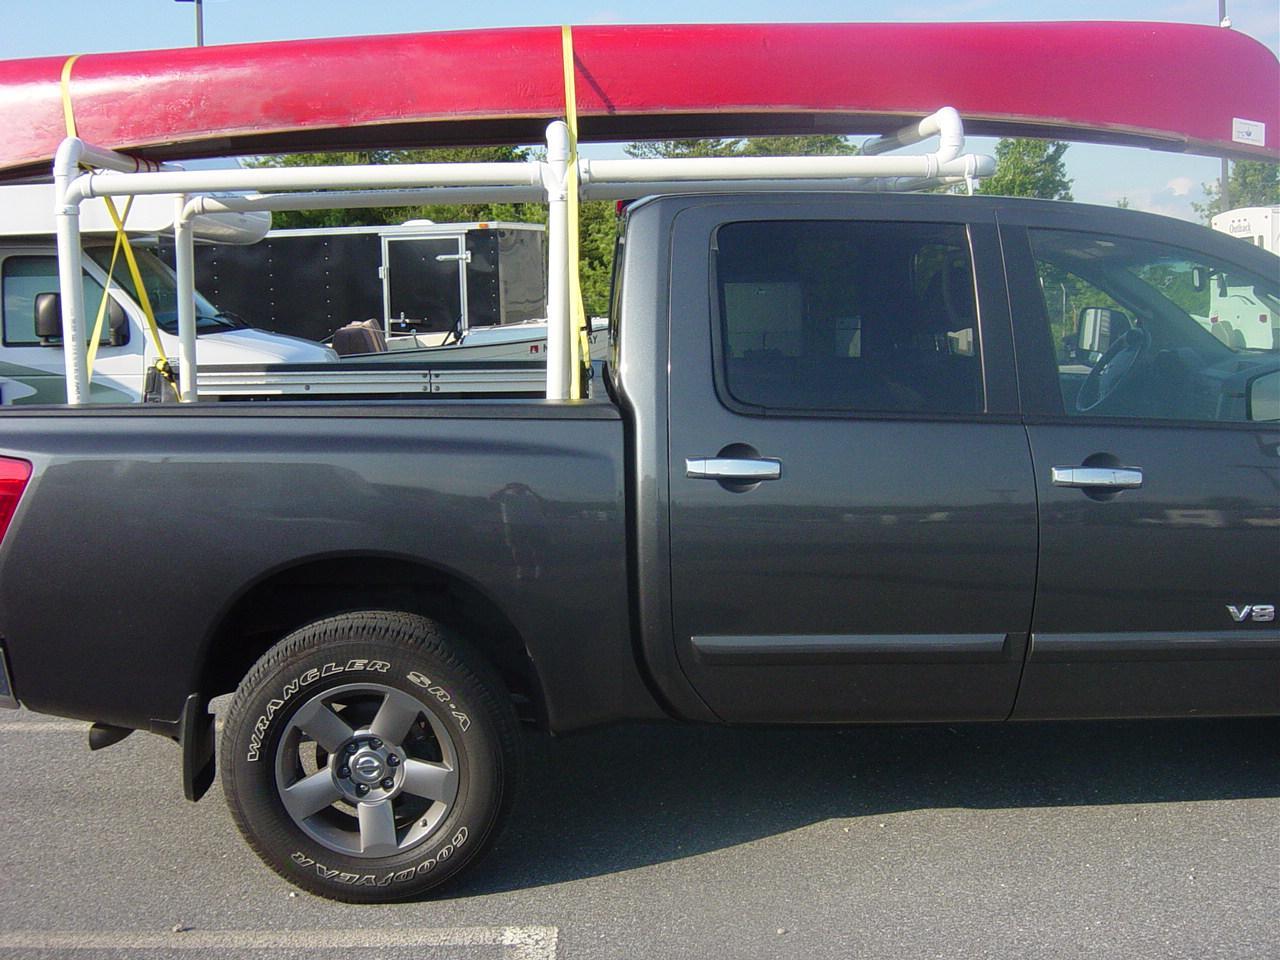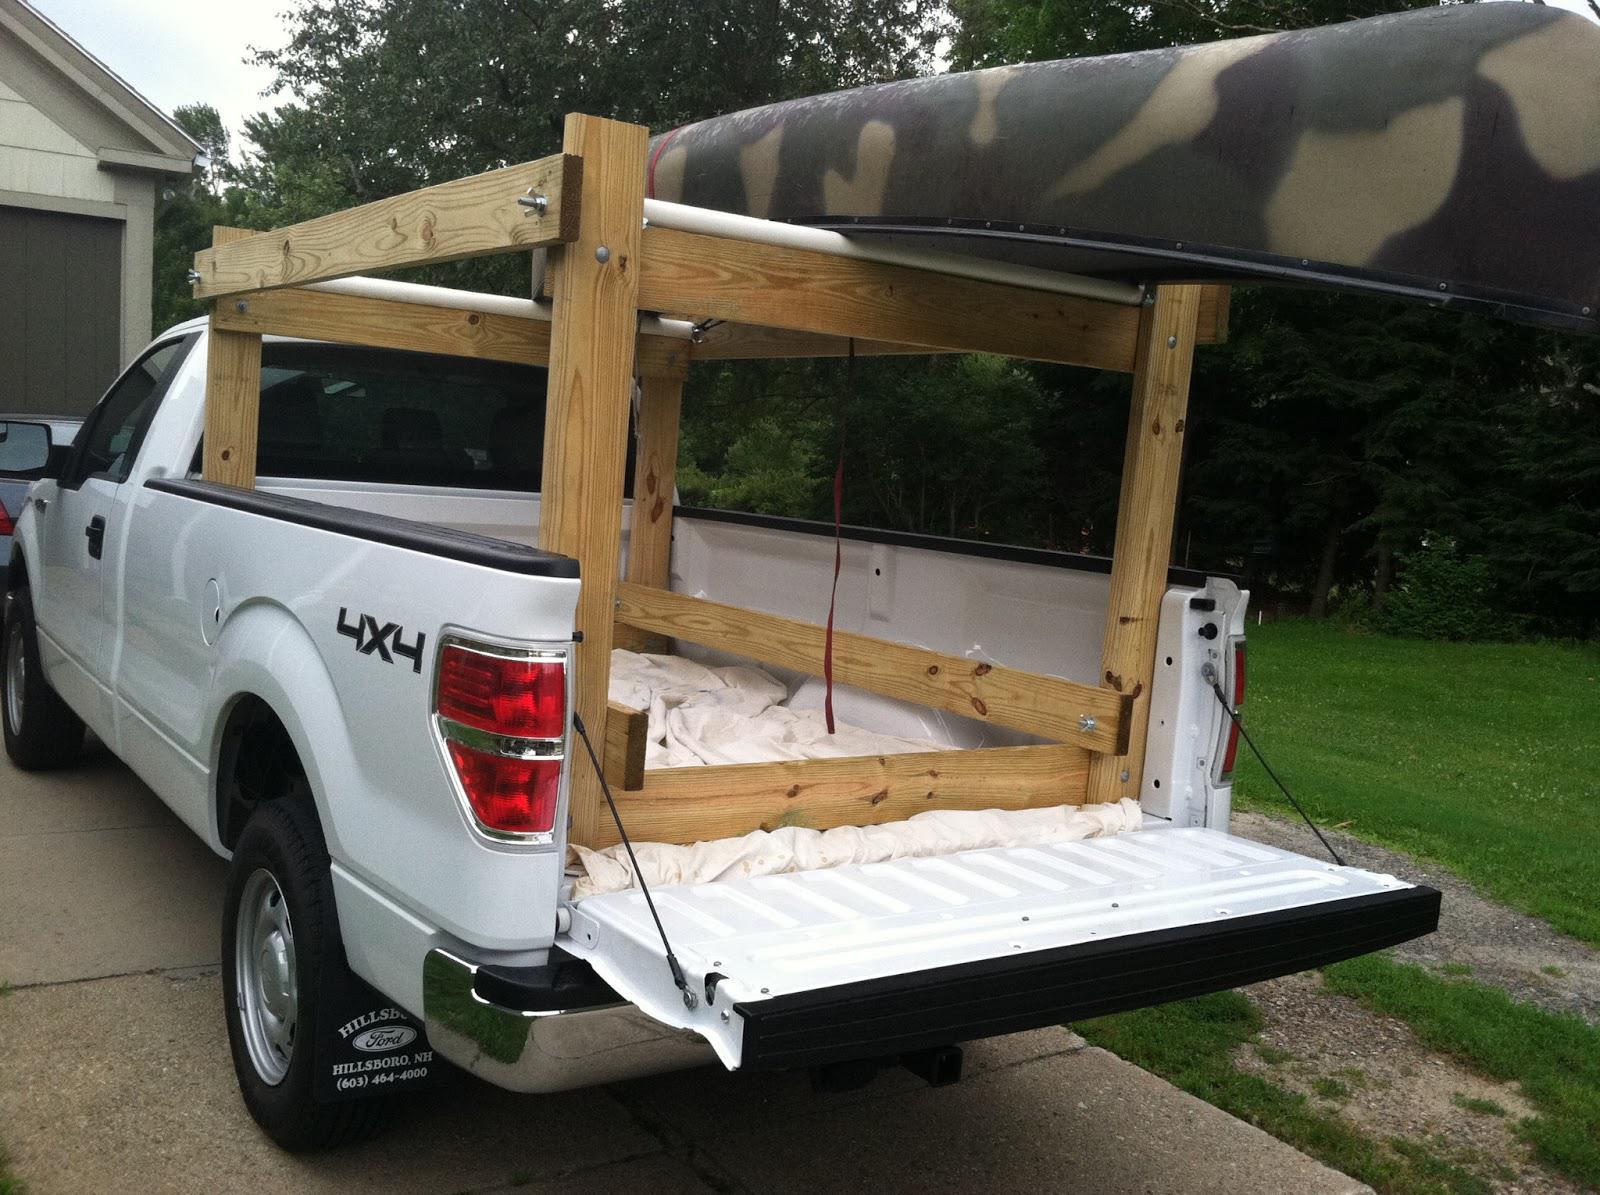The first image is the image on the left, the second image is the image on the right. For the images displayed, is the sentence "In one image, a canoe is strapped to the top of a blue pickup truck with wide silver trim on the lower panel." factually correct? Answer yes or no. No. 